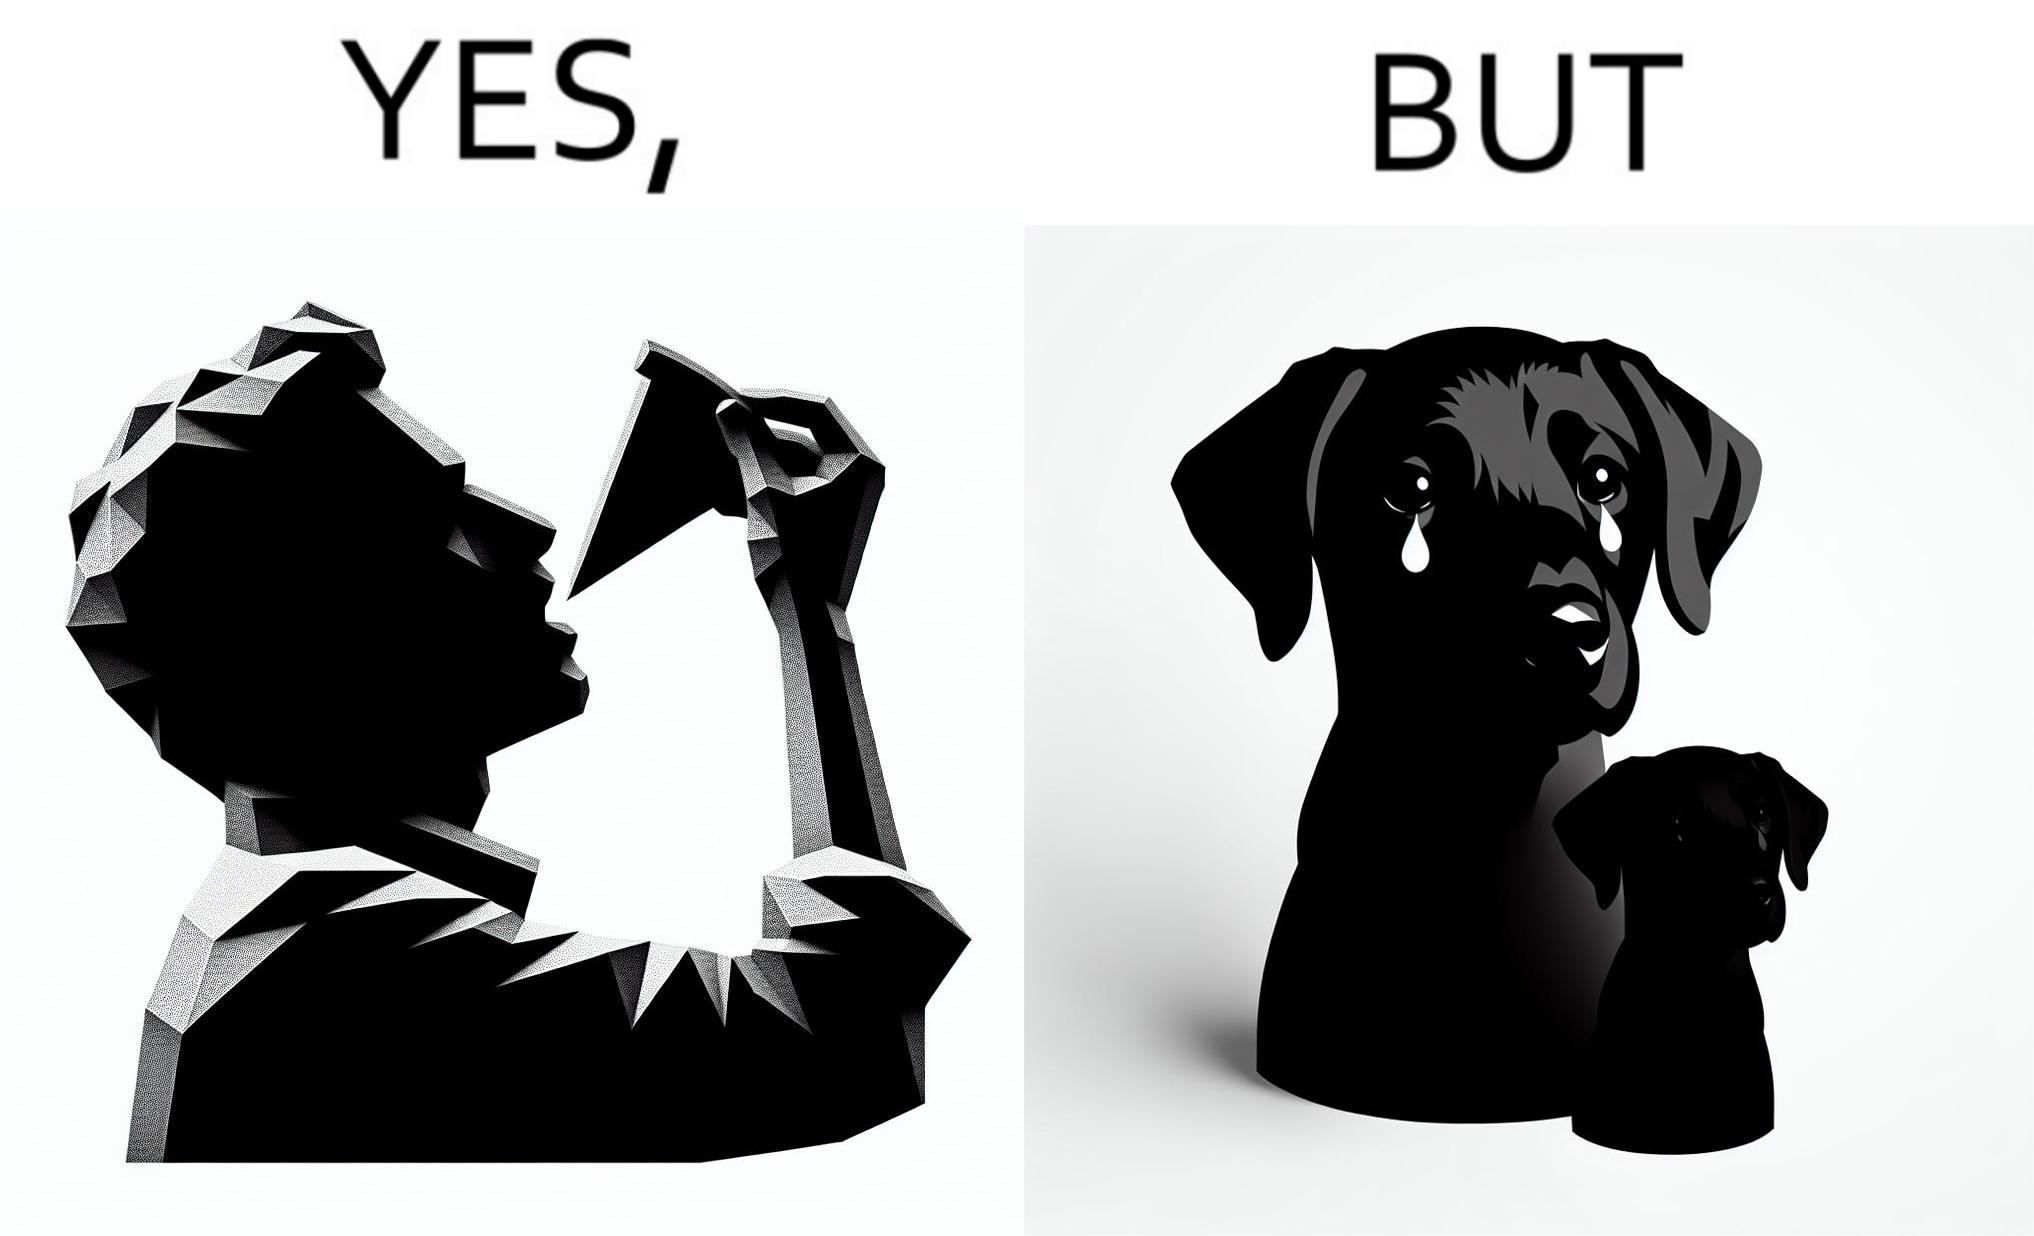Why is this image considered satirical? The images are funny since they show how pet owners cannot enjoy any tasty food like pizza without sharing with their pets. The look from the pets makes the owner too guilty if he does not share his food 